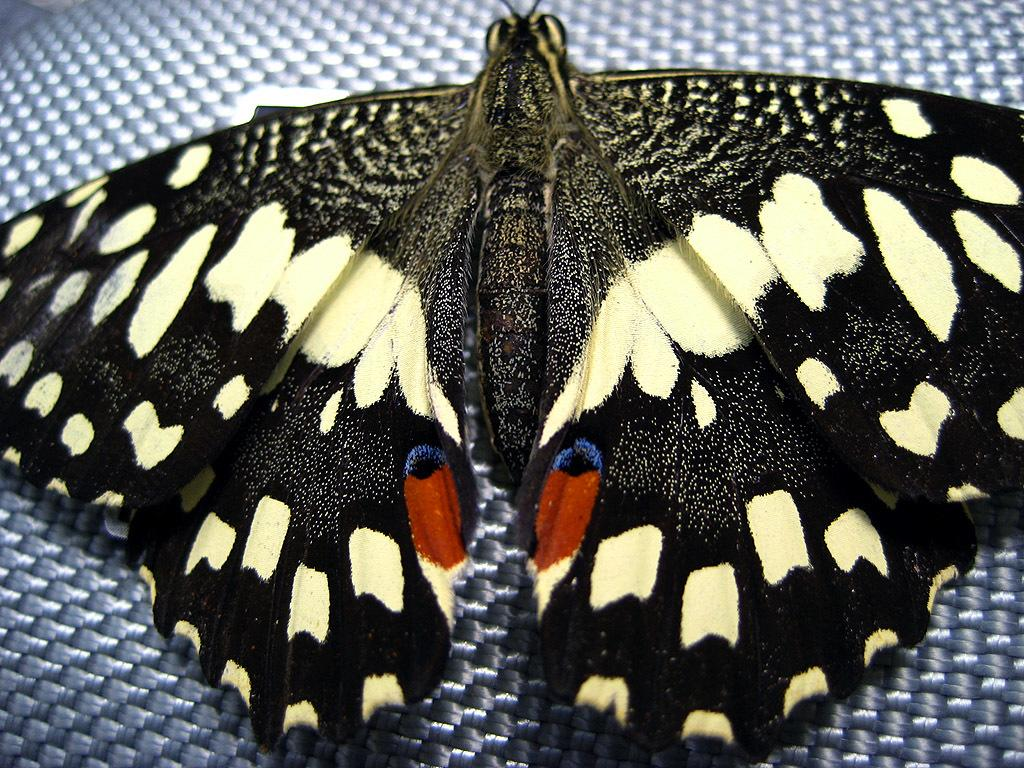What is the main subject of the image? There is a butterfly in the image. Can you describe the butterfly's appearance? The butterfly is black, white, red, and blue in color. What else can be seen in the image besides the butterfly? There is a surface in the image. How far away is the help that the butterfly needs in the image? There is no indication in the image that the butterfly needs help, and therefore no distance can be determined. 